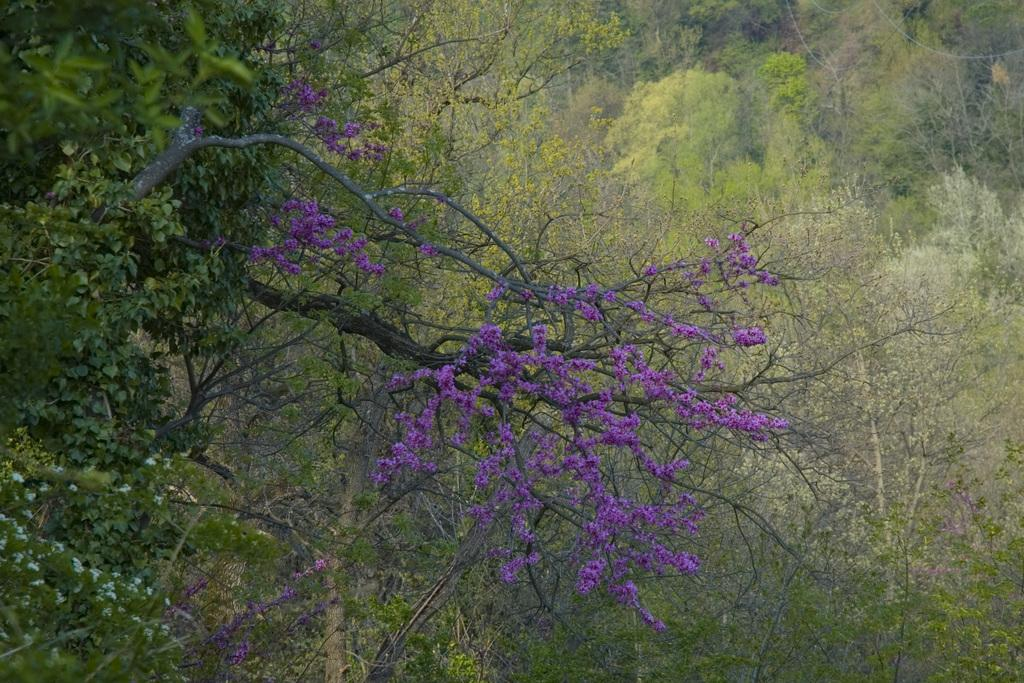What type of vegetation can be seen in the image? There are trees in the image. What additional feature can be observed on the trees? There are flowers on the trees. What else is visible towards the top of the image? There are wires visible towards the top of the image. What type of brass instrument is being played in the image? There is no brass instrument present in the image; it features trees with flowers and wires. Can you tell me how many books are visible on the sofa in the image? There is no sofa or book present in the image. 